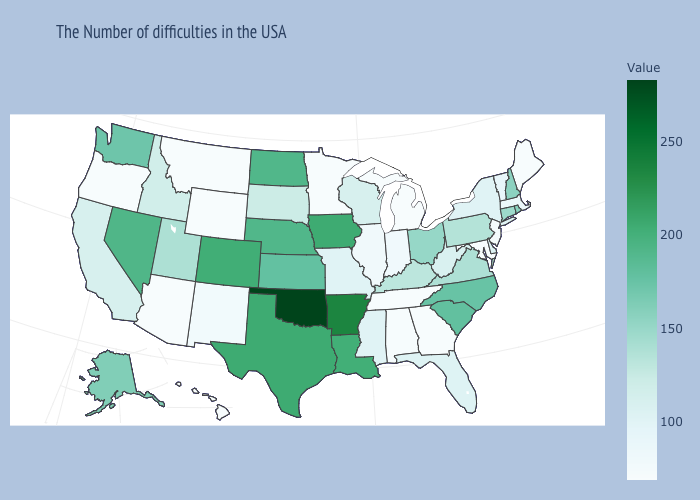Does Minnesota have the lowest value in the MidWest?
Keep it brief. Yes. Is the legend a continuous bar?
Keep it brief. Yes. 